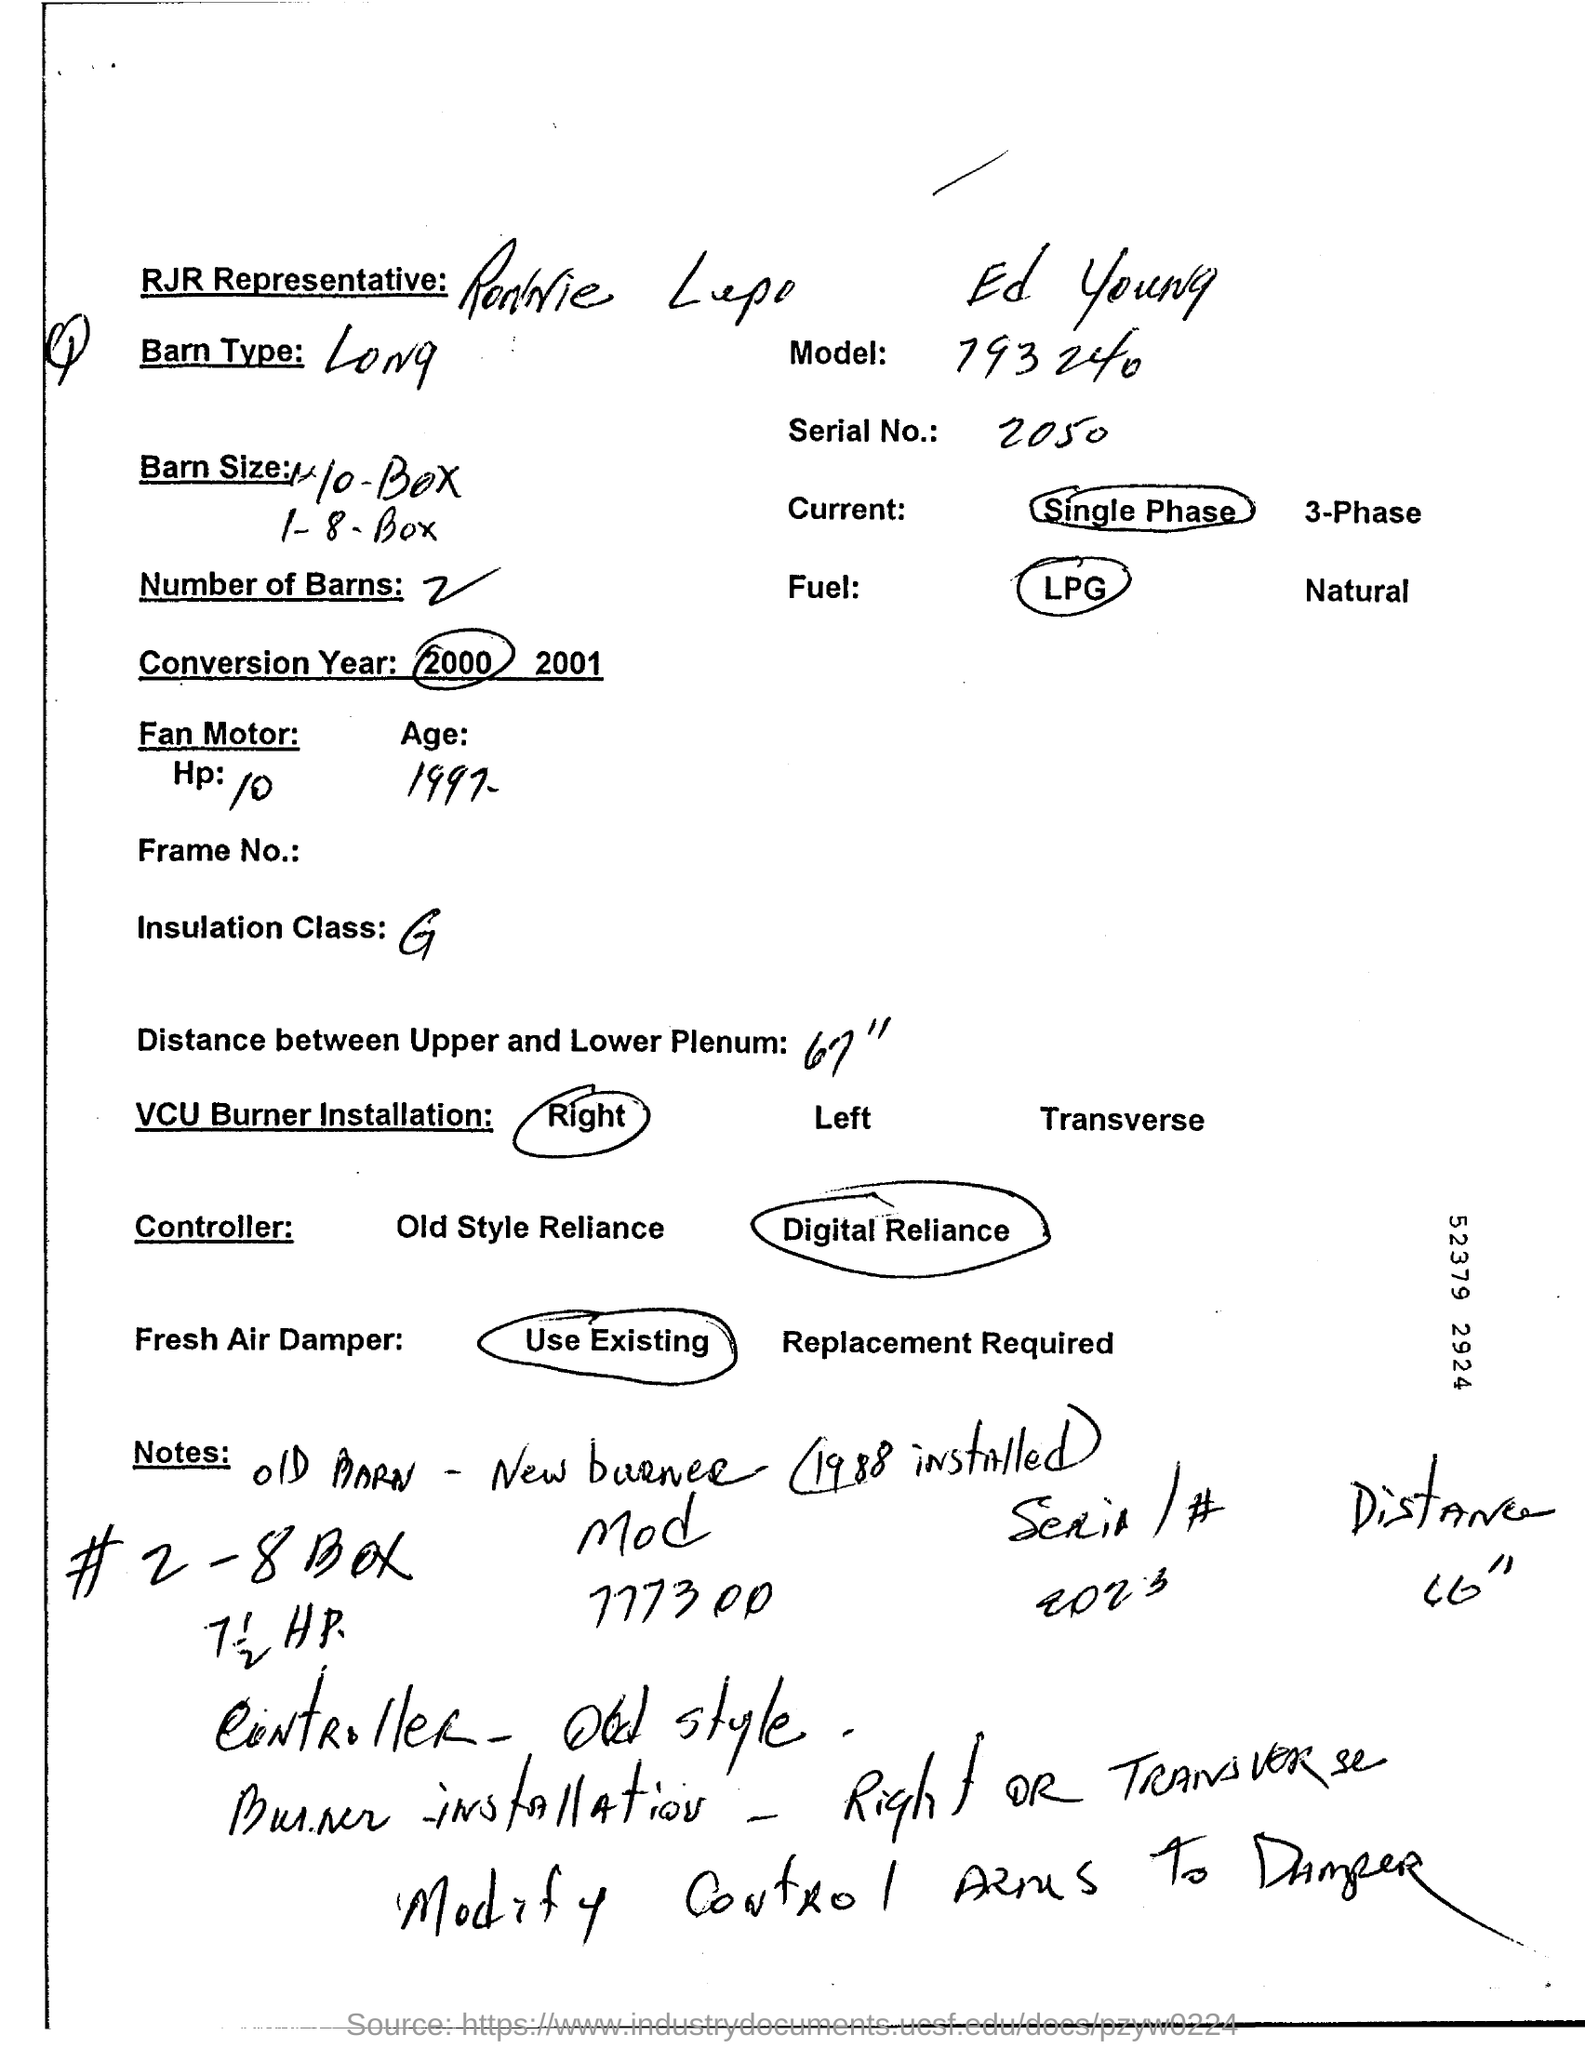Mention a couple of crucial points in this snapshot. The value of Serial No is 2050. The model number written on the page is 793240. 